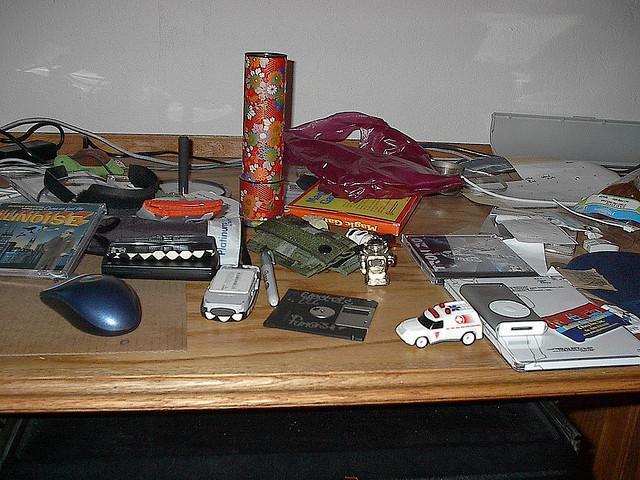How many books are visible?
Give a very brief answer. 2. 